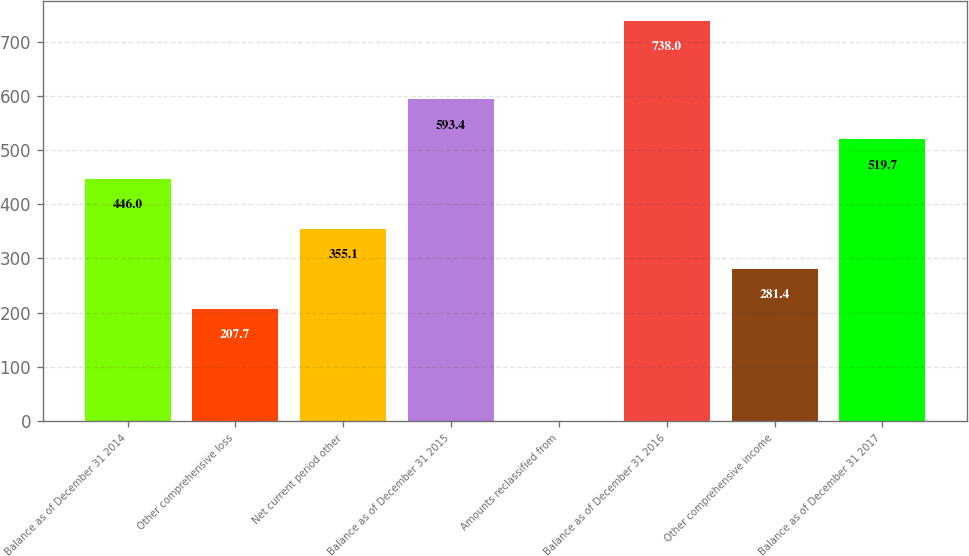Convert chart. <chart><loc_0><loc_0><loc_500><loc_500><bar_chart><fcel>Balance as of December 31 2014<fcel>Other comprehensive loss<fcel>Net current period other<fcel>Balance as of December 31 2015<fcel>Amounts reclassified from<fcel>Balance as of December 31 2016<fcel>Other comprehensive income<fcel>Balance as of December 31 2017<nl><fcel>446<fcel>207.7<fcel>355.1<fcel>593.4<fcel>1<fcel>738<fcel>281.4<fcel>519.7<nl></chart> 